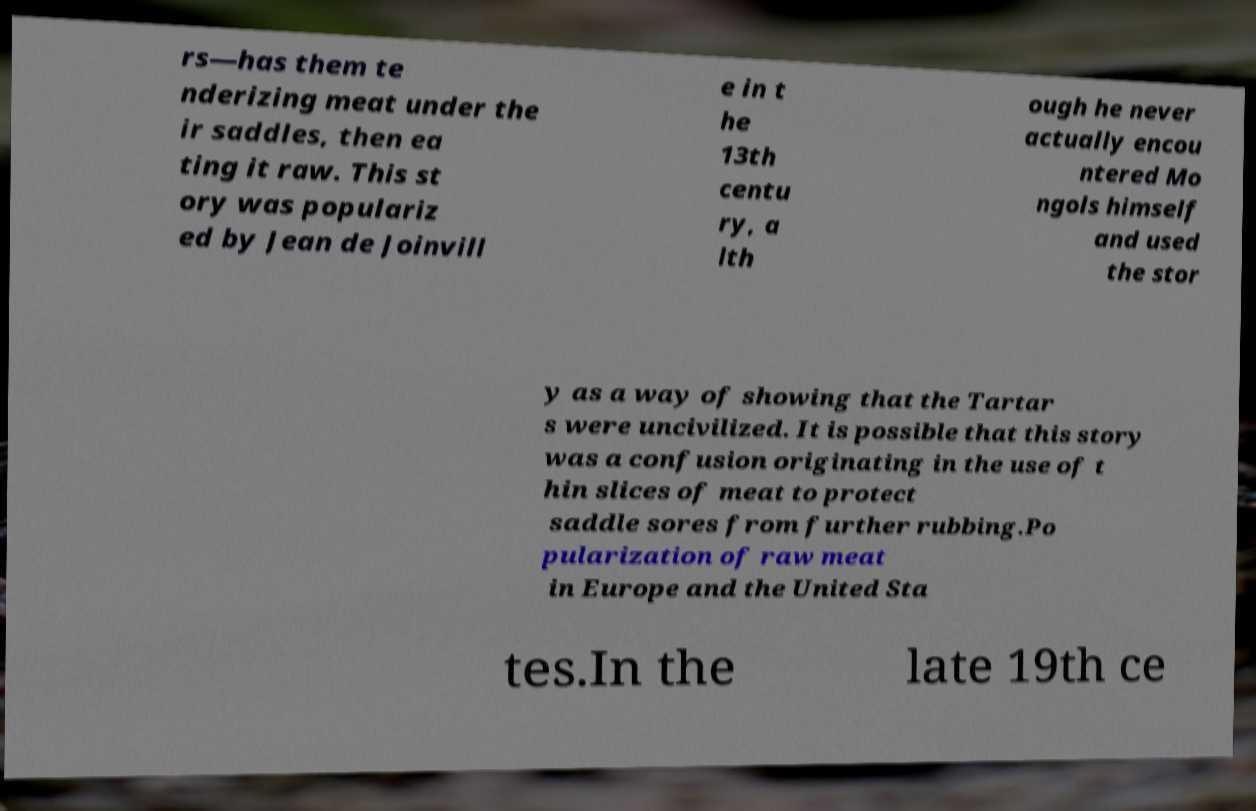Can you read and provide the text displayed in the image?This photo seems to have some interesting text. Can you extract and type it out for me? rs—has them te nderizing meat under the ir saddles, then ea ting it raw. This st ory was populariz ed by Jean de Joinvill e in t he 13th centu ry, a lth ough he never actually encou ntered Mo ngols himself and used the stor y as a way of showing that the Tartar s were uncivilized. It is possible that this story was a confusion originating in the use of t hin slices of meat to protect saddle sores from further rubbing.Po pularization of raw meat in Europe and the United Sta tes.In the late 19th ce 